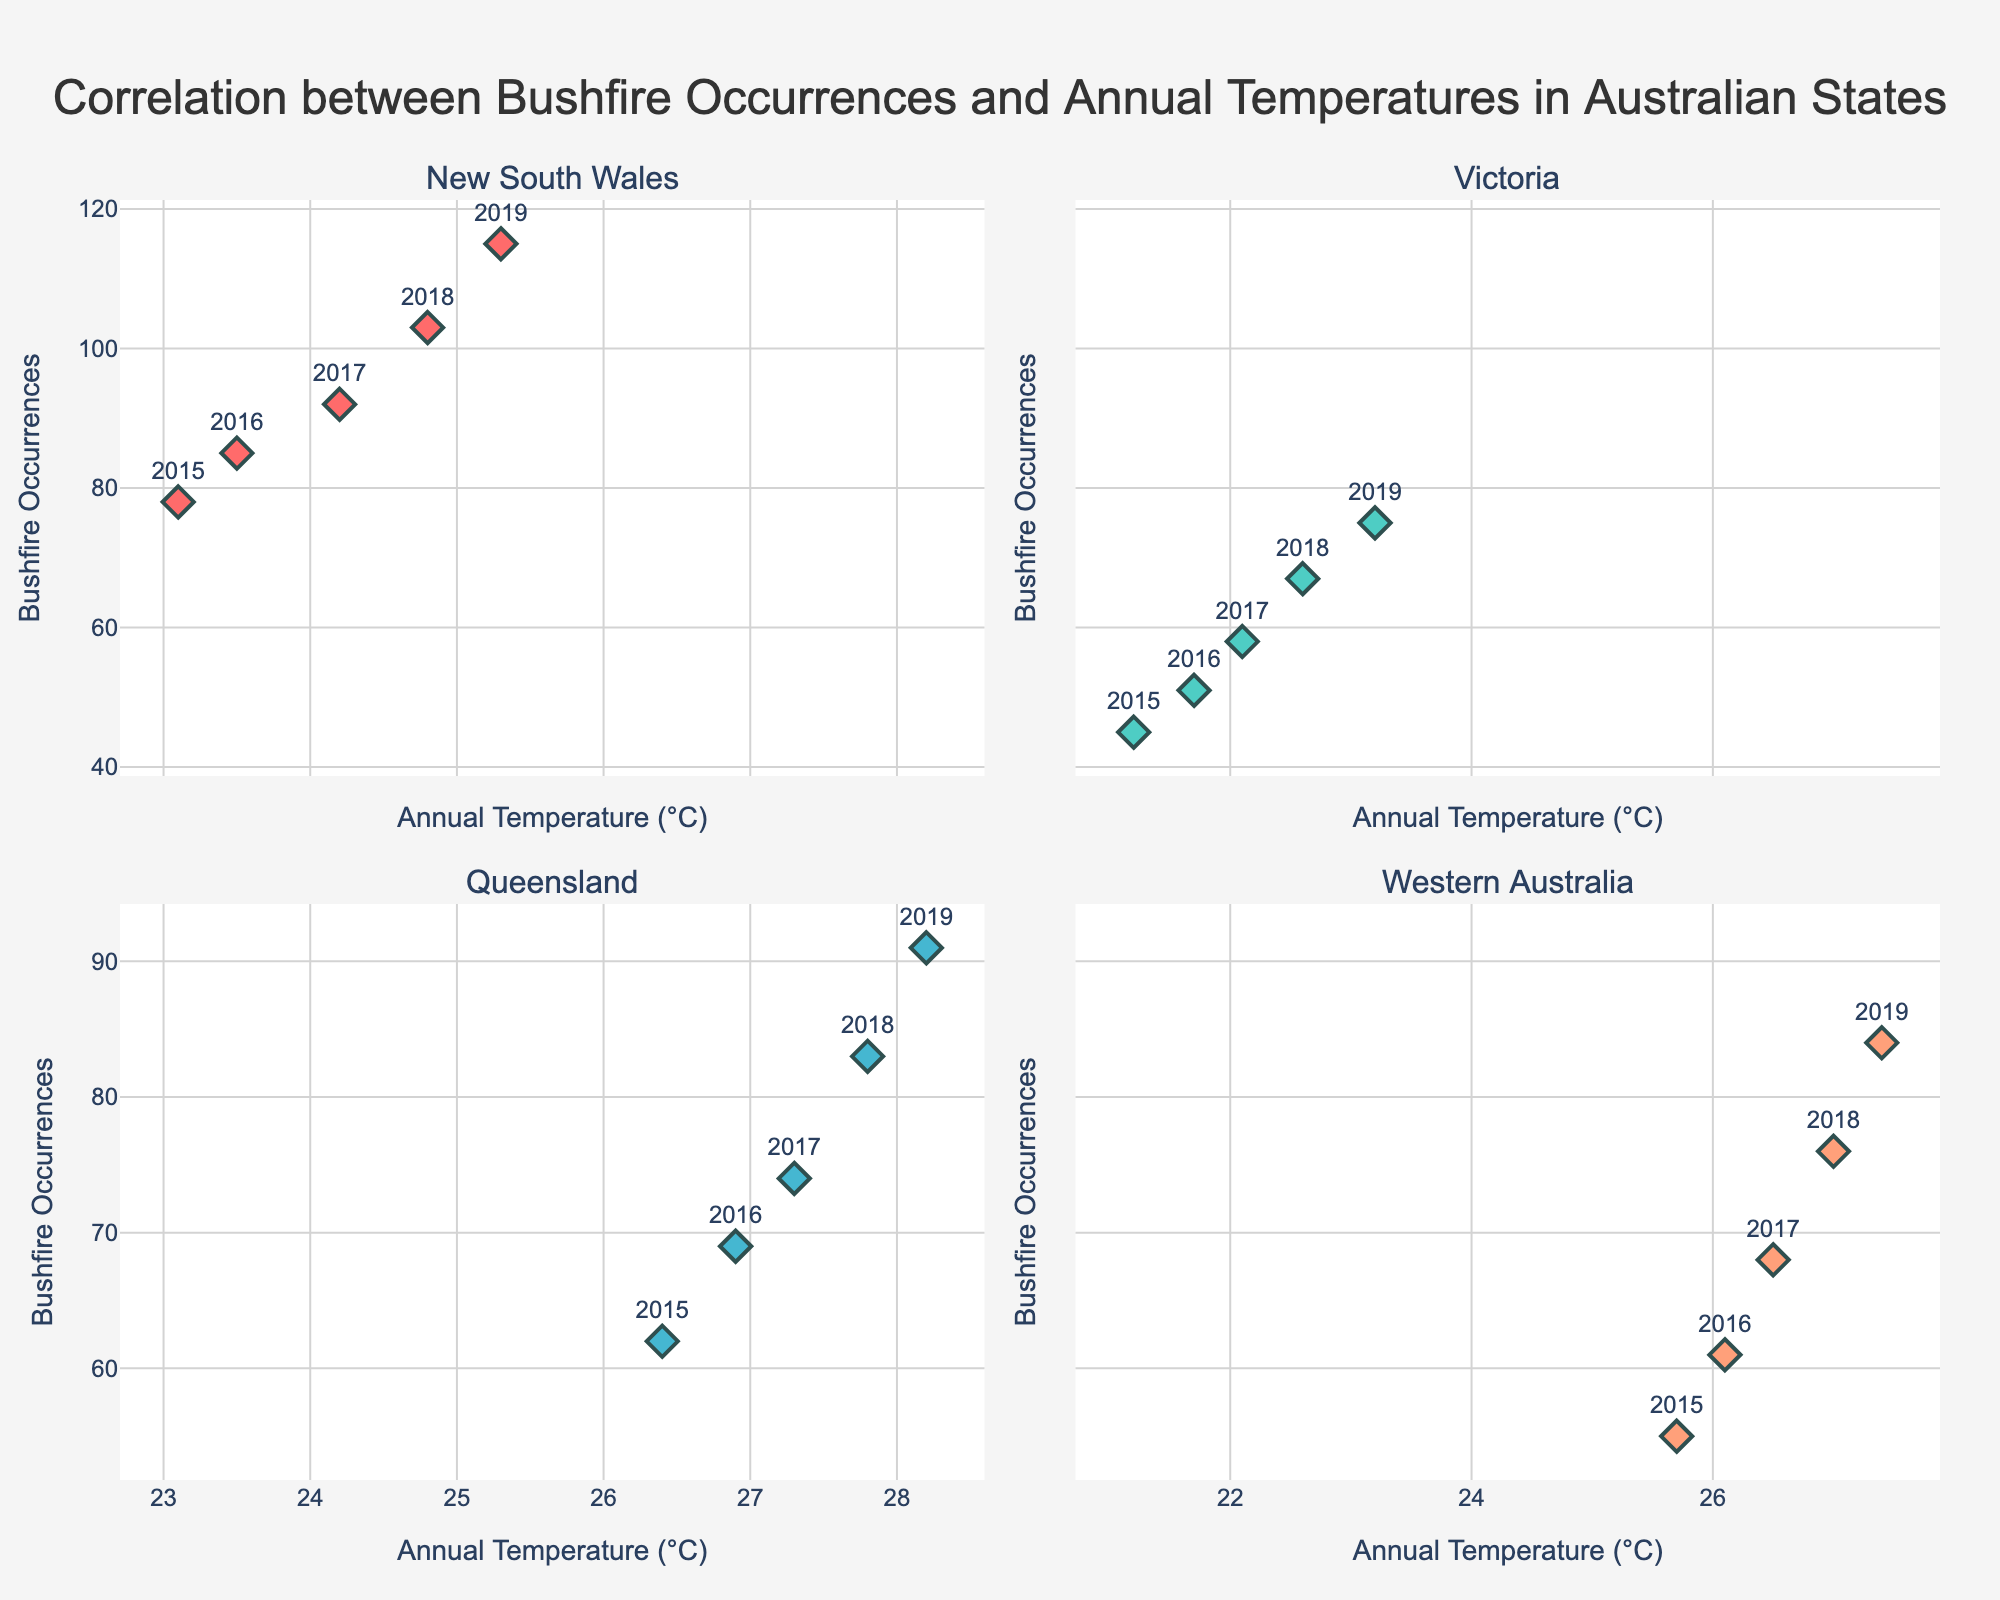What is the cost of the Inpainting technique? The bar chart indicating the cost of restoration techniques lists "Inpainting" with its respective cost displayed above the bar.
Answer: 7500 Which technique has the highest increase in value after restoration? The bar chart titled "Increase in Value after Restoration" shows that "Relining" has the highest value increase percentage.
Answer: Relining How many years does the Humidity Control System preserve a painting? The "Preservation Duration" chart shows the number of years each technique preserves a painting, and for Humidity Control System, it's labeled directly above the bar.
Answer: 30 Which technique costs more, Inpainting or Crack Repair? Comparing the heights of the bars in the "Cost of Restoration Techniques" chart, Crack Repair costs $8000 while Inpainting costs $7500.
Answer: Crack Repair What is the average preservation duration for all techniques? Sum all the preservation durations (25 + 30 + 40 + 20 + 35 + 15 + 30 + 25 + 20 + 30 = 270) and divide by the number of techniques (10).
Answer: 27 How does the cost of Deacidification compare to that of UV Protection Treatment? In the "Cost of Restoration Techniques" chart, Deacidification costs $5500 while UV Protection Treatment costs $3000.
Answer: Deacidification is more expensive What is the difference in value increase between Consolidation and Retouching? The "Increase in Value after Restoration" chart shows Consolidation has a 12% increase while Retouching has 7%. The difference is calculated as 12% - 7%.
Answer: 5% Which technique offers the longest preservation duration? The "Preservation Duration" chart indicates the Relining technique provides the longest duration of 40 years.
Answer: Relining What is the total cost of Varnish Removal and Reapplication, Cleaning, and Humidity Control System? Adding the costs from the respective bars: 5000 (Varnish Removal) + 3500 (Cleaning) + 4000 (Humidity Control System) = 12500.
Answer: 12500 